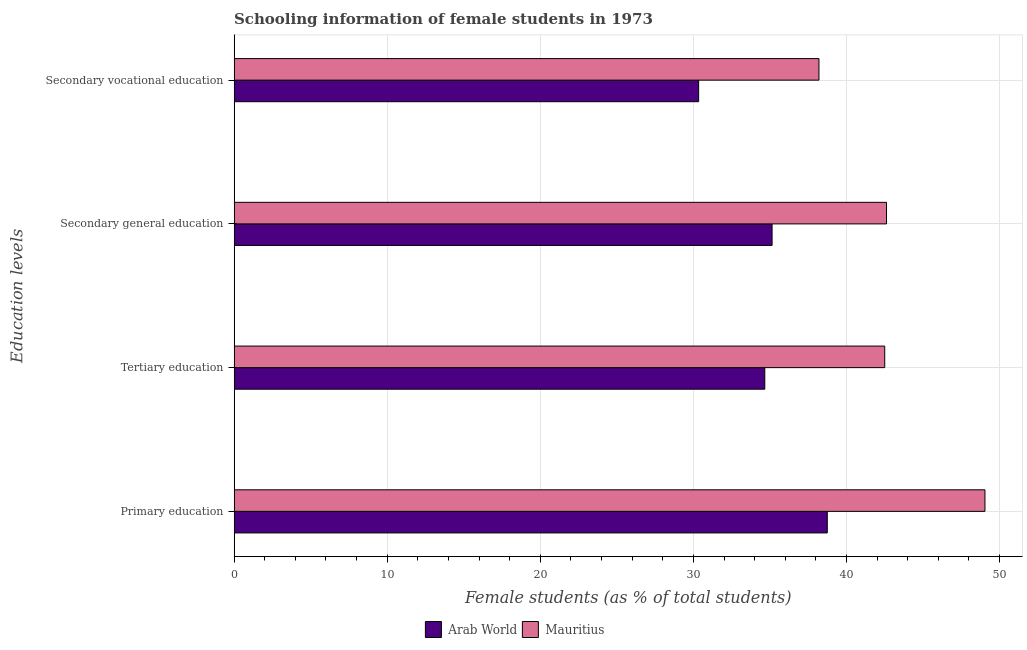How many different coloured bars are there?
Give a very brief answer. 2. How many groups of bars are there?
Keep it short and to the point. 4. How many bars are there on the 3rd tick from the top?
Offer a very short reply. 2. How many bars are there on the 1st tick from the bottom?
Ensure brevity in your answer.  2. What is the label of the 2nd group of bars from the top?
Make the answer very short. Secondary general education. What is the percentage of female students in tertiary education in Mauritius?
Ensure brevity in your answer.  42.5. Across all countries, what is the maximum percentage of female students in tertiary education?
Your response must be concise. 42.5. Across all countries, what is the minimum percentage of female students in secondary education?
Your response must be concise. 35.14. In which country was the percentage of female students in secondary education maximum?
Offer a terse response. Mauritius. In which country was the percentage of female students in tertiary education minimum?
Your response must be concise. Arab World. What is the total percentage of female students in secondary education in the graph?
Offer a very short reply. 77.76. What is the difference between the percentage of female students in tertiary education in Mauritius and that in Arab World?
Your response must be concise. 7.84. What is the difference between the percentage of female students in tertiary education in Mauritius and the percentage of female students in secondary education in Arab World?
Make the answer very short. 7.36. What is the average percentage of female students in primary education per country?
Offer a very short reply. 43.9. What is the difference between the percentage of female students in tertiary education and percentage of female students in secondary education in Mauritius?
Provide a succinct answer. -0.12. In how many countries, is the percentage of female students in secondary vocational education greater than 18 %?
Your answer should be very brief. 2. What is the ratio of the percentage of female students in primary education in Mauritius to that in Arab World?
Your response must be concise. 1.27. Is the percentage of female students in secondary vocational education in Arab World less than that in Mauritius?
Keep it short and to the point. Yes. Is the difference between the percentage of female students in tertiary education in Mauritius and Arab World greater than the difference between the percentage of female students in primary education in Mauritius and Arab World?
Give a very brief answer. No. What is the difference between the highest and the second highest percentage of female students in tertiary education?
Provide a short and direct response. 7.84. What is the difference between the highest and the lowest percentage of female students in primary education?
Your answer should be very brief. 10.3. Is the sum of the percentage of female students in secondary vocational education in Arab World and Mauritius greater than the maximum percentage of female students in primary education across all countries?
Offer a very short reply. Yes. What does the 1st bar from the top in Secondary general education represents?
Your answer should be compact. Mauritius. What does the 2nd bar from the bottom in Tertiary education represents?
Keep it short and to the point. Mauritius. How many bars are there?
Keep it short and to the point. 8. Are all the bars in the graph horizontal?
Make the answer very short. Yes. What is the difference between two consecutive major ticks on the X-axis?
Make the answer very short. 10. Are the values on the major ticks of X-axis written in scientific E-notation?
Offer a very short reply. No. Does the graph contain grids?
Offer a very short reply. Yes. How many legend labels are there?
Your response must be concise. 2. What is the title of the graph?
Keep it short and to the point. Schooling information of female students in 1973. What is the label or title of the X-axis?
Your answer should be very brief. Female students (as % of total students). What is the label or title of the Y-axis?
Your answer should be very brief. Education levels. What is the Female students (as % of total students) in Arab World in Primary education?
Make the answer very short. 38.75. What is the Female students (as % of total students) in Mauritius in Primary education?
Provide a succinct answer. 49.05. What is the Female students (as % of total students) in Arab World in Tertiary education?
Make the answer very short. 34.66. What is the Female students (as % of total students) of Mauritius in Tertiary education?
Give a very brief answer. 42.5. What is the Female students (as % of total students) of Arab World in Secondary general education?
Provide a succinct answer. 35.14. What is the Female students (as % of total students) in Mauritius in Secondary general education?
Offer a terse response. 42.62. What is the Female students (as % of total students) of Arab World in Secondary vocational education?
Offer a very short reply. 30.34. What is the Female students (as % of total students) of Mauritius in Secondary vocational education?
Give a very brief answer. 38.2. Across all Education levels, what is the maximum Female students (as % of total students) in Arab World?
Offer a terse response. 38.75. Across all Education levels, what is the maximum Female students (as % of total students) of Mauritius?
Ensure brevity in your answer.  49.05. Across all Education levels, what is the minimum Female students (as % of total students) in Arab World?
Your answer should be compact. 30.34. Across all Education levels, what is the minimum Female students (as % of total students) of Mauritius?
Your response must be concise. 38.2. What is the total Female students (as % of total students) of Arab World in the graph?
Offer a terse response. 138.89. What is the total Female students (as % of total students) in Mauritius in the graph?
Ensure brevity in your answer.  172.36. What is the difference between the Female students (as % of total students) of Arab World in Primary education and that in Tertiary education?
Make the answer very short. 4.08. What is the difference between the Female students (as % of total students) of Mauritius in Primary education and that in Tertiary education?
Give a very brief answer. 6.55. What is the difference between the Female students (as % of total students) in Arab World in Primary education and that in Secondary general education?
Give a very brief answer. 3.61. What is the difference between the Female students (as % of total students) of Mauritius in Primary education and that in Secondary general education?
Make the answer very short. 6.43. What is the difference between the Female students (as % of total students) in Arab World in Primary education and that in Secondary vocational education?
Provide a succinct answer. 8.4. What is the difference between the Female students (as % of total students) of Mauritius in Primary education and that in Secondary vocational education?
Provide a short and direct response. 10.84. What is the difference between the Female students (as % of total students) in Arab World in Tertiary education and that in Secondary general education?
Your answer should be very brief. -0.48. What is the difference between the Female students (as % of total students) in Mauritius in Tertiary education and that in Secondary general education?
Provide a short and direct response. -0.12. What is the difference between the Female students (as % of total students) in Arab World in Tertiary education and that in Secondary vocational education?
Your answer should be compact. 4.32. What is the difference between the Female students (as % of total students) in Mauritius in Tertiary education and that in Secondary vocational education?
Offer a terse response. 4.3. What is the difference between the Female students (as % of total students) in Arab World in Secondary general education and that in Secondary vocational education?
Provide a succinct answer. 4.8. What is the difference between the Female students (as % of total students) in Mauritius in Secondary general education and that in Secondary vocational education?
Your answer should be compact. 4.41. What is the difference between the Female students (as % of total students) in Arab World in Primary education and the Female students (as % of total students) in Mauritius in Tertiary education?
Your answer should be very brief. -3.75. What is the difference between the Female students (as % of total students) in Arab World in Primary education and the Female students (as % of total students) in Mauritius in Secondary general education?
Your response must be concise. -3.87. What is the difference between the Female students (as % of total students) of Arab World in Primary education and the Female students (as % of total students) of Mauritius in Secondary vocational education?
Provide a short and direct response. 0.54. What is the difference between the Female students (as % of total students) in Arab World in Tertiary education and the Female students (as % of total students) in Mauritius in Secondary general education?
Provide a succinct answer. -7.95. What is the difference between the Female students (as % of total students) of Arab World in Tertiary education and the Female students (as % of total students) of Mauritius in Secondary vocational education?
Your answer should be very brief. -3.54. What is the difference between the Female students (as % of total students) in Arab World in Secondary general education and the Female students (as % of total students) in Mauritius in Secondary vocational education?
Keep it short and to the point. -3.06. What is the average Female students (as % of total students) of Arab World per Education levels?
Your response must be concise. 34.72. What is the average Female students (as % of total students) in Mauritius per Education levels?
Offer a very short reply. 43.09. What is the difference between the Female students (as % of total students) in Arab World and Female students (as % of total students) in Mauritius in Primary education?
Give a very brief answer. -10.3. What is the difference between the Female students (as % of total students) in Arab World and Female students (as % of total students) in Mauritius in Tertiary education?
Give a very brief answer. -7.84. What is the difference between the Female students (as % of total students) of Arab World and Female students (as % of total students) of Mauritius in Secondary general education?
Keep it short and to the point. -7.47. What is the difference between the Female students (as % of total students) of Arab World and Female students (as % of total students) of Mauritius in Secondary vocational education?
Provide a succinct answer. -7.86. What is the ratio of the Female students (as % of total students) in Arab World in Primary education to that in Tertiary education?
Provide a short and direct response. 1.12. What is the ratio of the Female students (as % of total students) in Mauritius in Primary education to that in Tertiary education?
Provide a short and direct response. 1.15. What is the ratio of the Female students (as % of total students) of Arab World in Primary education to that in Secondary general education?
Provide a short and direct response. 1.1. What is the ratio of the Female students (as % of total students) of Mauritius in Primary education to that in Secondary general education?
Your response must be concise. 1.15. What is the ratio of the Female students (as % of total students) of Arab World in Primary education to that in Secondary vocational education?
Keep it short and to the point. 1.28. What is the ratio of the Female students (as % of total students) of Mauritius in Primary education to that in Secondary vocational education?
Offer a terse response. 1.28. What is the ratio of the Female students (as % of total students) in Arab World in Tertiary education to that in Secondary general education?
Make the answer very short. 0.99. What is the ratio of the Female students (as % of total students) in Mauritius in Tertiary education to that in Secondary general education?
Provide a short and direct response. 1. What is the ratio of the Female students (as % of total students) in Arab World in Tertiary education to that in Secondary vocational education?
Make the answer very short. 1.14. What is the ratio of the Female students (as % of total students) in Mauritius in Tertiary education to that in Secondary vocational education?
Offer a terse response. 1.11. What is the ratio of the Female students (as % of total students) of Arab World in Secondary general education to that in Secondary vocational education?
Your answer should be very brief. 1.16. What is the ratio of the Female students (as % of total students) in Mauritius in Secondary general education to that in Secondary vocational education?
Offer a terse response. 1.12. What is the difference between the highest and the second highest Female students (as % of total students) of Arab World?
Provide a succinct answer. 3.61. What is the difference between the highest and the second highest Female students (as % of total students) of Mauritius?
Your response must be concise. 6.43. What is the difference between the highest and the lowest Female students (as % of total students) in Arab World?
Provide a short and direct response. 8.4. What is the difference between the highest and the lowest Female students (as % of total students) in Mauritius?
Provide a succinct answer. 10.84. 